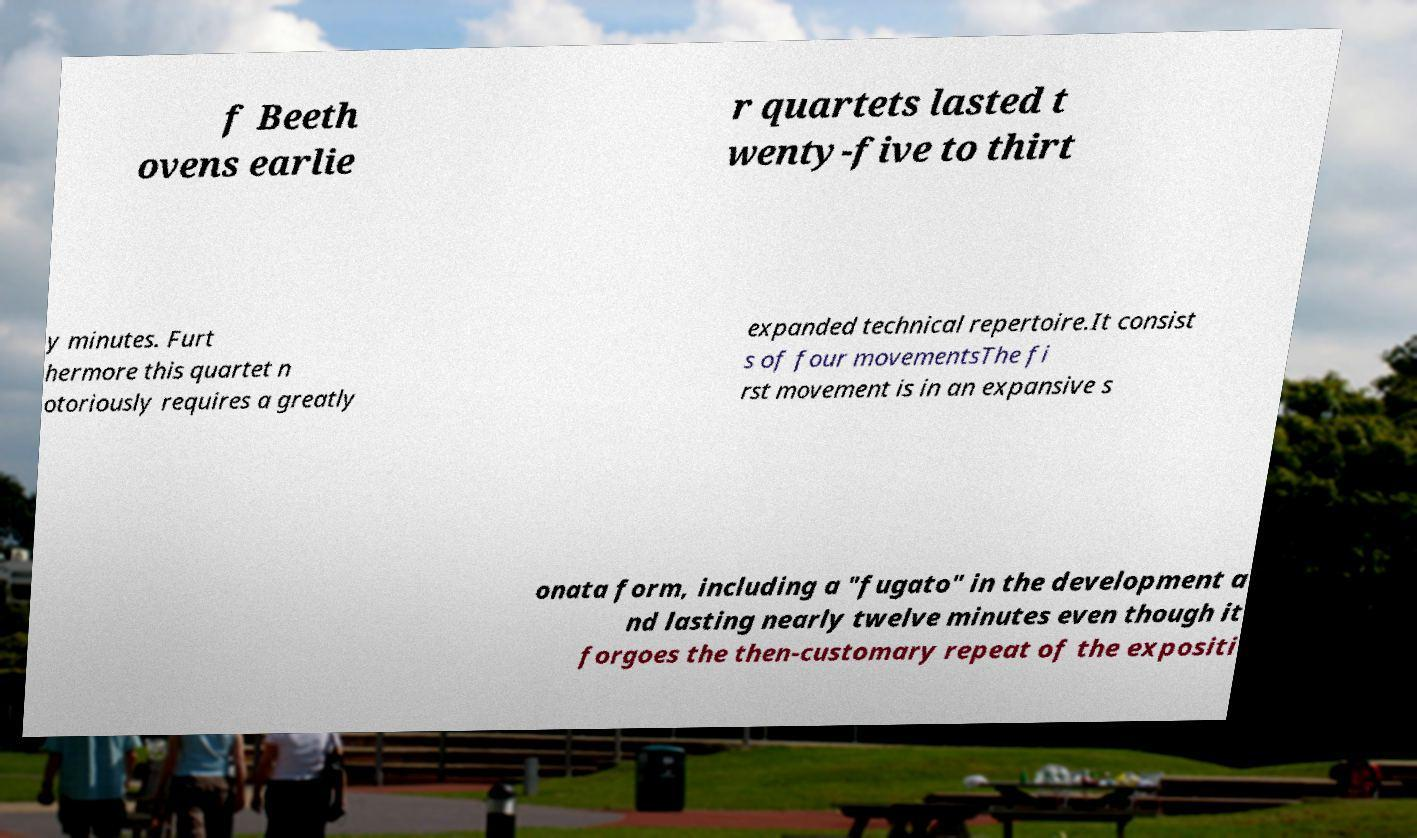What messages or text are displayed in this image? I need them in a readable, typed format. f Beeth ovens earlie r quartets lasted t wenty-five to thirt y minutes. Furt hermore this quartet n otoriously requires a greatly expanded technical repertoire.It consist s of four movementsThe fi rst movement is in an expansive s onata form, including a "fugato" in the development a nd lasting nearly twelve minutes even though it forgoes the then-customary repeat of the expositi 